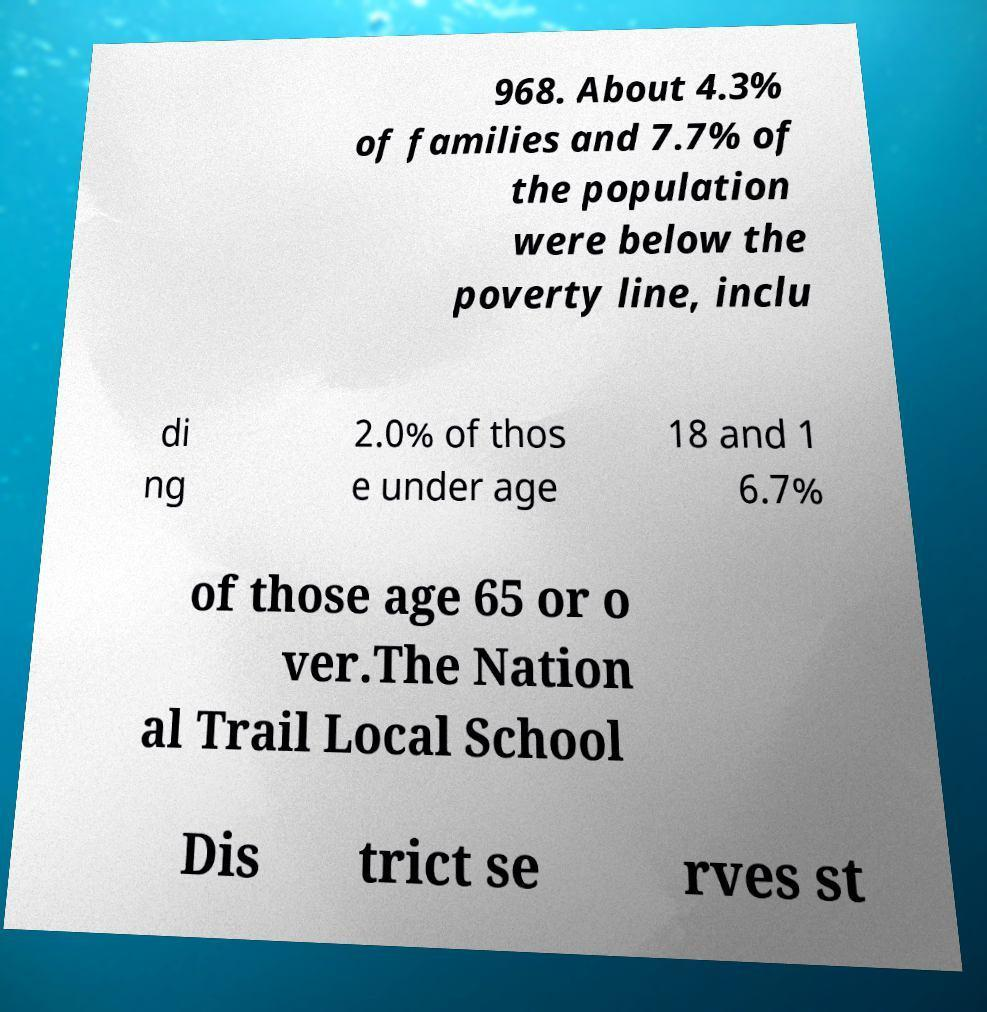For documentation purposes, I need the text within this image transcribed. Could you provide that? 968. About 4.3% of families and 7.7% of the population were below the poverty line, inclu di ng 2.0% of thos e under age 18 and 1 6.7% of those age 65 or o ver.The Nation al Trail Local School Dis trict se rves st 